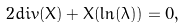<formula> <loc_0><loc_0><loc_500><loc_500>2 d i v ( X ) + X ( \ln ( \lambda ) ) = 0 ,</formula> 